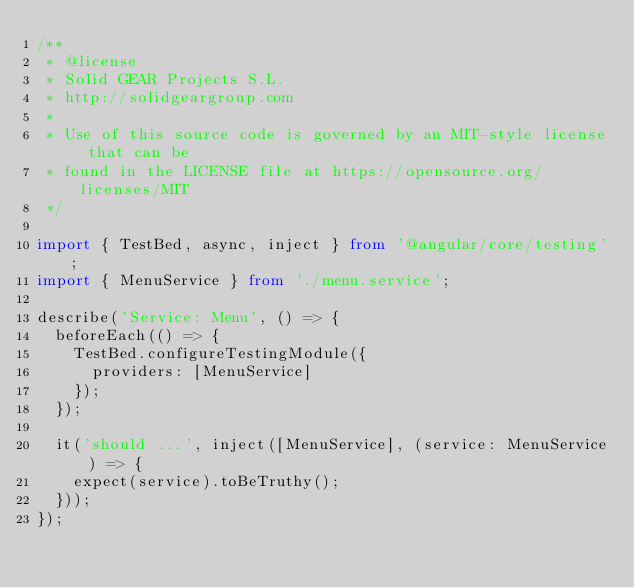Convert code to text. <code><loc_0><loc_0><loc_500><loc_500><_TypeScript_>/**
 * @license
 * Solid GEAR Projects S.L.
 * http://solidgeargroup.com
 *
 * Use of this source code is governed by an MIT-style license that can be
 * found in the LICENSE file at https://opensource.org/licenses/MIT
 */

import { TestBed, async, inject } from '@angular/core/testing';
import { MenuService } from './menu.service';

describe('Service: Menu', () => {
  beforeEach(() => {
    TestBed.configureTestingModule({
      providers: [MenuService]
    });
  });

  it('should ...', inject([MenuService], (service: MenuService) => {
    expect(service).toBeTruthy();
  }));
});
</code> 